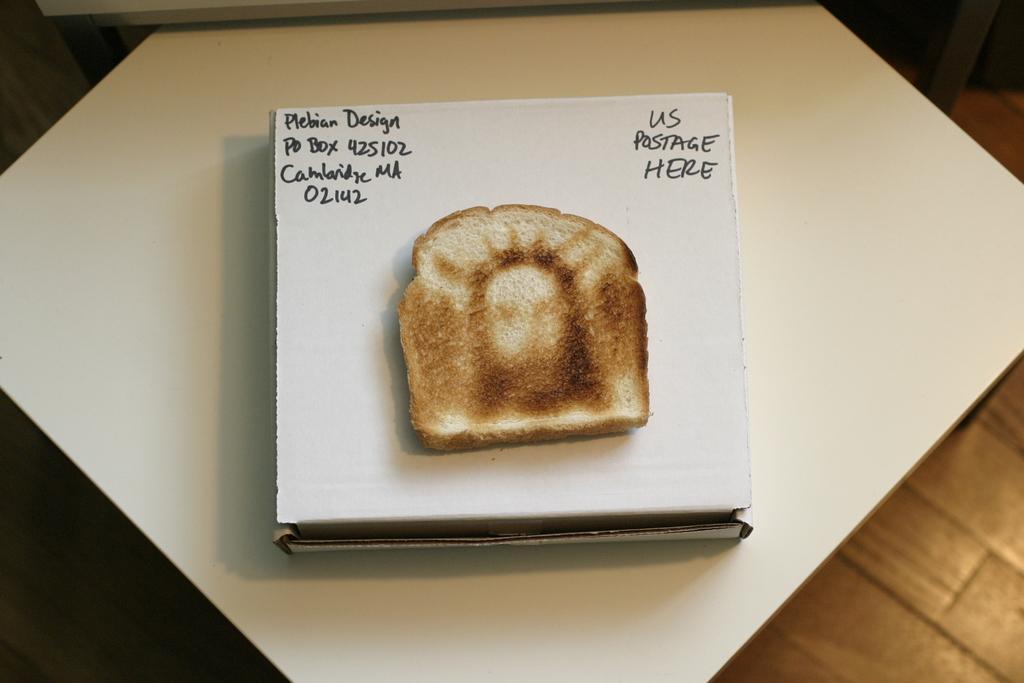How would you summarize this image in a sentence or two? In the foreground of this image, there is a bread piece on a cardboard box which is on a white table. In the background, there is wooden floor. 